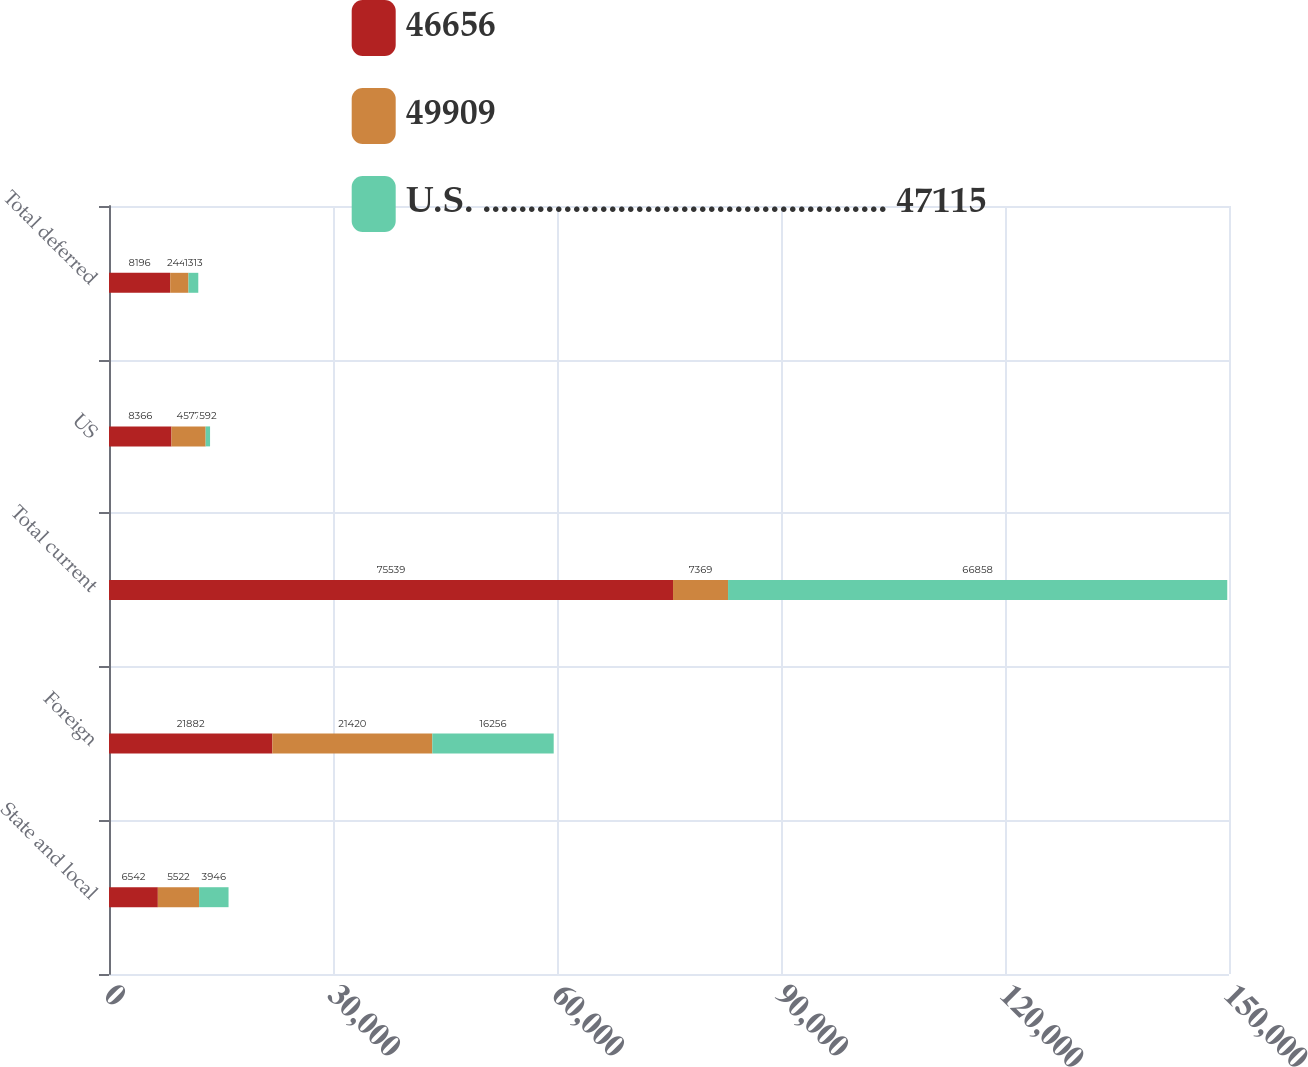<chart> <loc_0><loc_0><loc_500><loc_500><stacked_bar_chart><ecel><fcel>State and local<fcel>Foreign<fcel>Total current<fcel>US<fcel>Total deferred<nl><fcel>46656<fcel>6542<fcel>21882<fcel>75539<fcel>8366<fcel>8196<nl><fcel>49909<fcel>5522<fcel>21420<fcel>7369<fcel>4577<fcel>2449<nl><fcel>U.S. ............................................. 47115<fcel>3946<fcel>16256<fcel>66858<fcel>592<fcel>1313<nl></chart> 